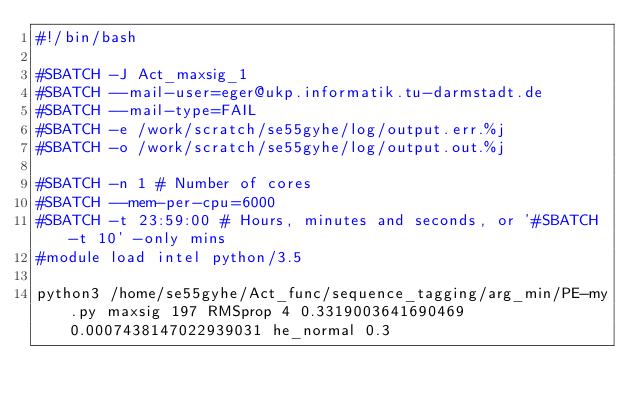Convert code to text. <code><loc_0><loc_0><loc_500><loc_500><_Bash_>#!/bin/bash
 
#SBATCH -J Act_maxsig_1
#SBATCH --mail-user=eger@ukp.informatik.tu-darmstadt.de
#SBATCH --mail-type=FAIL
#SBATCH -e /work/scratch/se55gyhe/log/output.err.%j
#SBATCH -o /work/scratch/se55gyhe/log/output.out.%j

#SBATCH -n 1 # Number of cores
#SBATCH --mem-per-cpu=6000
#SBATCH -t 23:59:00 # Hours, minutes and seconds, or '#SBATCH -t 10' -only mins
#module load intel python/3.5

python3 /home/se55gyhe/Act_func/sequence_tagging/arg_min/PE-my.py maxsig 197 RMSprop 4 0.3319003641690469 0.0007438147022939031 he_normal 0.3

</code> 